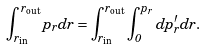<formula> <loc_0><loc_0><loc_500><loc_500>\int _ { r _ { \text {in} } } ^ { r _ { \text {out} } } p _ { r } d r = \int _ { r _ { \text {in} } } ^ { r _ { \text {out} } } \int _ { 0 } ^ { p _ { r } } d p ^ { \prime } _ { r } d r .</formula> 